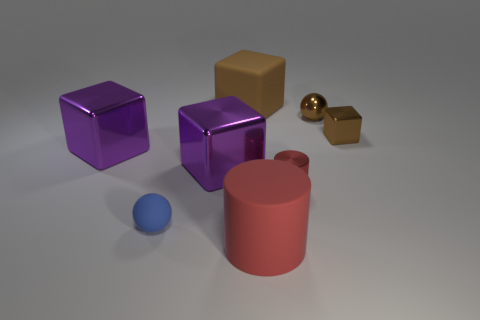There is another block that is the same color as the tiny metal cube; what is its material?
Offer a terse response. Rubber. Do the blue rubber ball and the brown shiny object that is to the left of the tiny brown block have the same size?
Keep it short and to the point. Yes. What number of other things are there of the same size as the blue matte sphere?
Give a very brief answer. 3. What number of other things are the same color as the shiny sphere?
Give a very brief answer. 2. Is there anything else that has the same size as the red metal cylinder?
Make the answer very short. Yes. How many other things are there of the same shape as the big brown thing?
Keep it short and to the point. 3. Is the size of the red matte thing the same as the metal cylinder?
Give a very brief answer. No. Is there a big red matte thing?
Give a very brief answer. Yes. Is there any other thing that has the same material as the big cylinder?
Provide a short and direct response. Yes. Is there a ball made of the same material as the large brown cube?
Provide a short and direct response. Yes. 